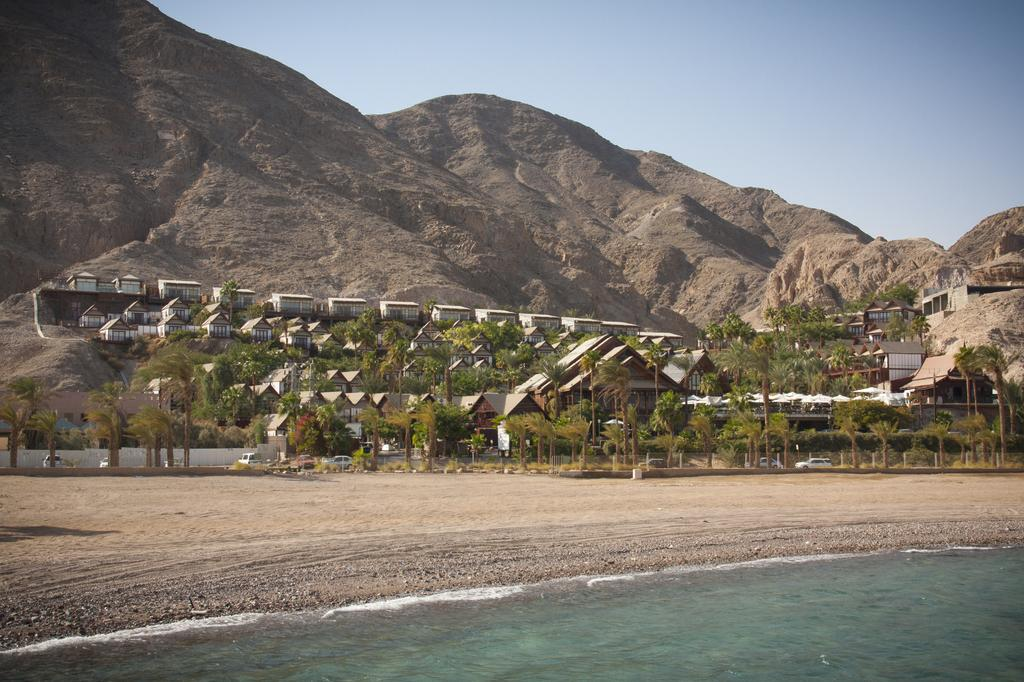What is visible in the front of the image? There is water in the front of the image. What can be seen in the background of the image? There are trees, buildings, and mountains in the background of the image. What type of clouds can be seen adjusting the answers in the image? There are no clouds or answers present in the image. 